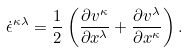<formula> <loc_0><loc_0><loc_500><loc_500>\dot { \epsilon } ^ { \kappa \lambda } = \frac { 1 } { 2 } \left ( \frac { \partial v ^ { \kappa } } { \partial x ^ { \lambda } } + \frac { \partial v ^ { \lambda } } { \partial x ^ { \kappa } } \right ) .</formula> 